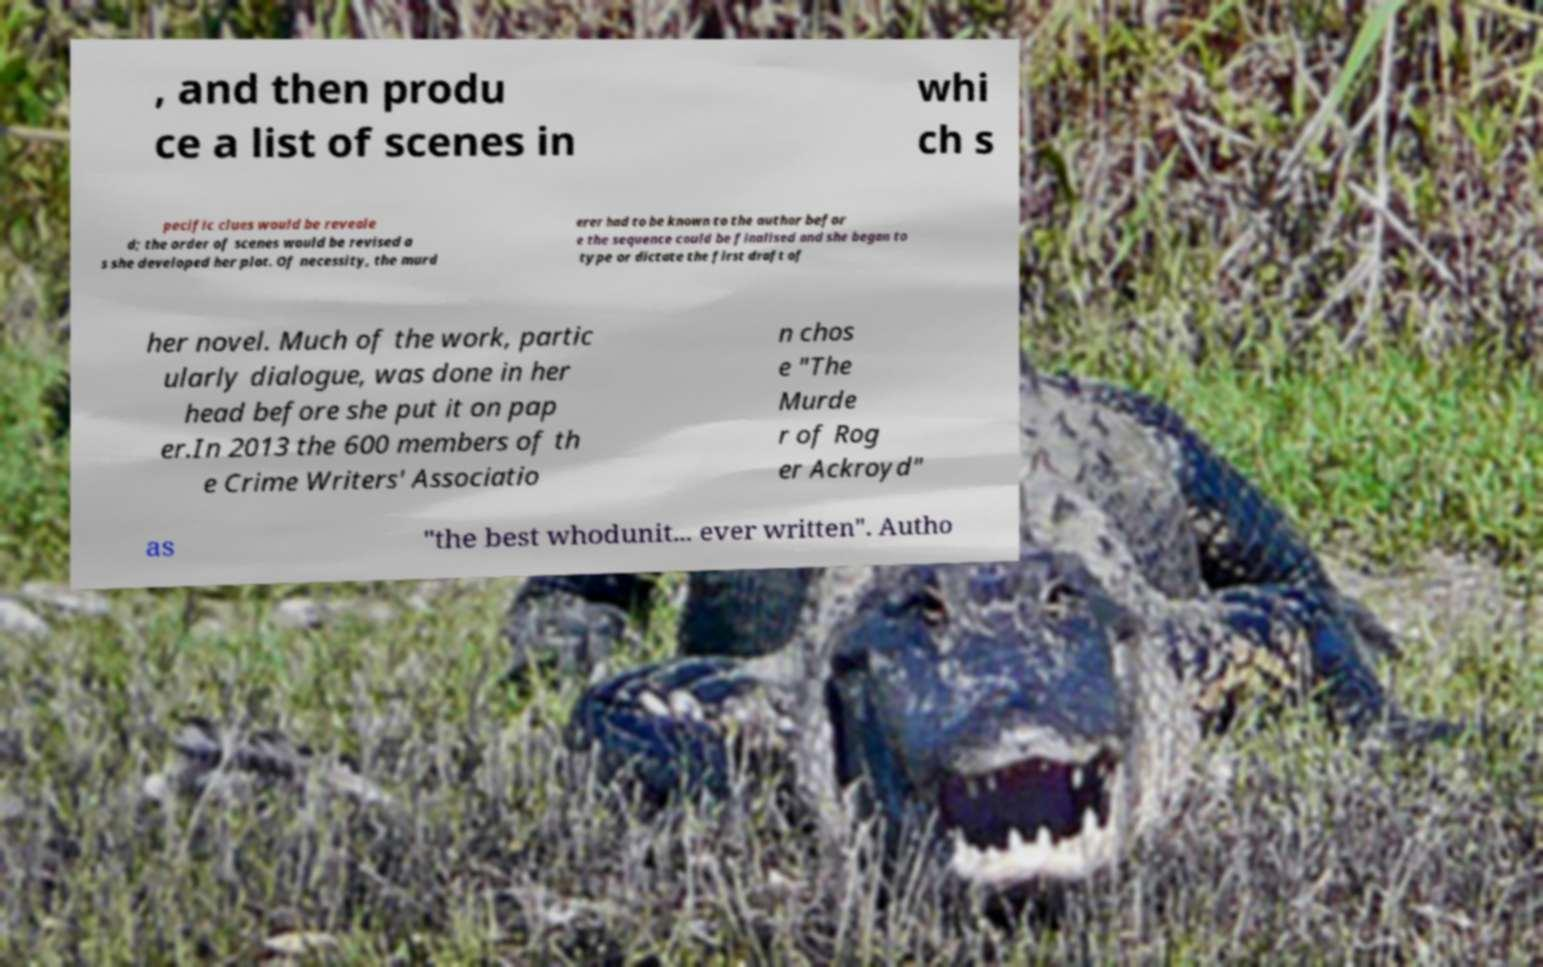Please identify and transcribe the text found in this image. , and then produ ce a list of scenes in whi ch s pecific clues would be reveale d; the order of scenes would be revised a s she developed her plot. Of necessity, the murd erer had to be known to the author befor e the sequence could be finalised and she began to type or dictate the first draft of her novel. Much of the work, partic ularly dialogue, was done in her head before she put it on pap er.In 2013 the 600 members of th e Crime Writers' Associatio n chos e "The Murde r of Rog er Ackroyd" as "the best whodunit... ever written". Autho 